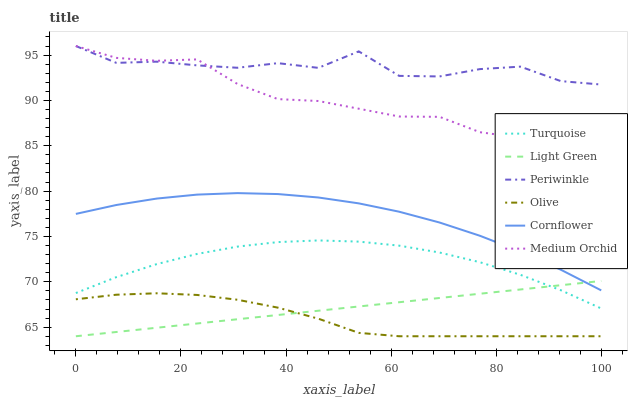Does Olive have the minimum area under the curve?
Answer yes or no. Yes. Does Periwinkle have the maximum area under the curve?
Answer yes or no. Yes. Does Turquoise have the minimum area under the curve?
Answer yes or no. No. Does Turquoise have the maximum area under the curve?
Answer yes or no. No. Is Light Green the smoothest?
Answer yes or no. Yes. Is Periwinkle the roughest?
Answer yes or no. Yes. Is Turquoise the smoothest?
Answer yes or no. No. Is Turquoise the roughest?
Answer yes or no. No. Does Light Green have the lowest value?
Answer yes or no. Yes. Does Turquoise have the lowest value?
Answer yes or no. No. Does Periwinkle have the highest value?
Answer yes or no. Yes. Does Turquoise have the highest value?
Answer yes or no. No. Is Olive less than Turquoise?
Answer yes or no. Yes. Is Cornflower greater than Turquoise?
Answer yes or no. Yes. Does Turquoise intersect Light Green?
Answer yes or no. Yes. Is Turquoise less than Light Green?
Answer yes or no. No. Is Turquoise greater than Light Green?
Answer yes or no. No. Does Olive intersect Turquoise?
Answer yes or no. No. 